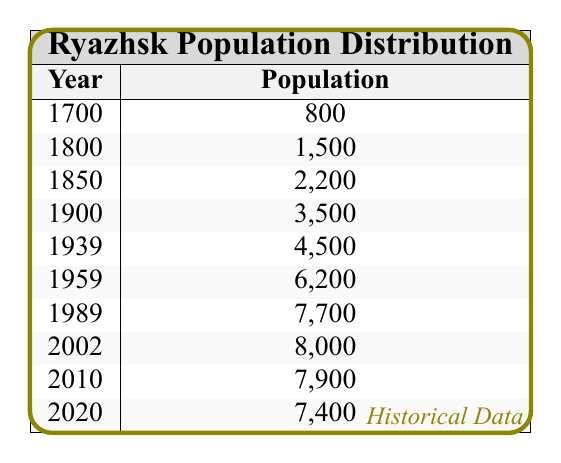What was the population of Ryazhsk in the year 1900? According to the table, the population figure for the year 1900 is directly stated as 3,500.
Answer: 3,500 What year had the highest population in Ryazhsk? The table shows that the highest population recorded is 8,000 in the year 2002.
Answer: 2002 What is the population difference between 1939 and 1959? To find the difference, subtract the population of 1939 (4,500) from 1959 (6,200). Calculation: 6,200 - 4,500 = 1,700.
Answer: 1,700 Was the population of Ryazhsk in 1800 greater than 2,000? The table states the population for 1800 is 1,500, which is less than 2,000, so the answer is no.
Answer: No What was the average population of Ryazhsk between 1700 and 1900? To calculate the average, first, we sum the populations for the years 1700 (800), 1800 (1,500), 1850 (2,200), and 1900 (3,500). The total is 800 + 1,500 + 2,200 + 3,500 = 8,000. There are 4 entries, so the average is 8,000 / 4 = 2,000.
Answer: 2,000 Is it true that the population increased every decade in the 20th century from 1900 to 2000? Checking the populations from 1900 (3,500), to 1939 (4,500), to 1959 (6,200), to 1989 (7,700), and finally to 2002 (8,000), we see that the population consistently increased during those decades. Thus, the statement is true.
Answer: Yes What was the population trend in Ryazhsk from 2002 to 2020? By comparing the years 2002 (8,000) and 2010 (7,900), there was a slight decrease to 7,900. Then, there was further decrease to 7,400 in 2020. Thus, the trend indicates a decline in population during this period.
Answer: Decrease How much did the population grow from 1800 to 1989? To find the growth, subtract the population of 1800 (1,500) from 1989 (7,700). The calculation will show 7,700 - 1,500 = 6,200.
Answer: 6,200 What is the median population for the years listed? To find the median, we first list the populations in ascending order: 800, 1,500, 2,200, 3,500, 4,500, 6,200, 7,700, 8,000, 7,900, 7,400. There are 10 values, so the median will be the average of the 5th and 6th values: (4,500 + 6,200) / 2 = 5,400.
Answer: 5,400 